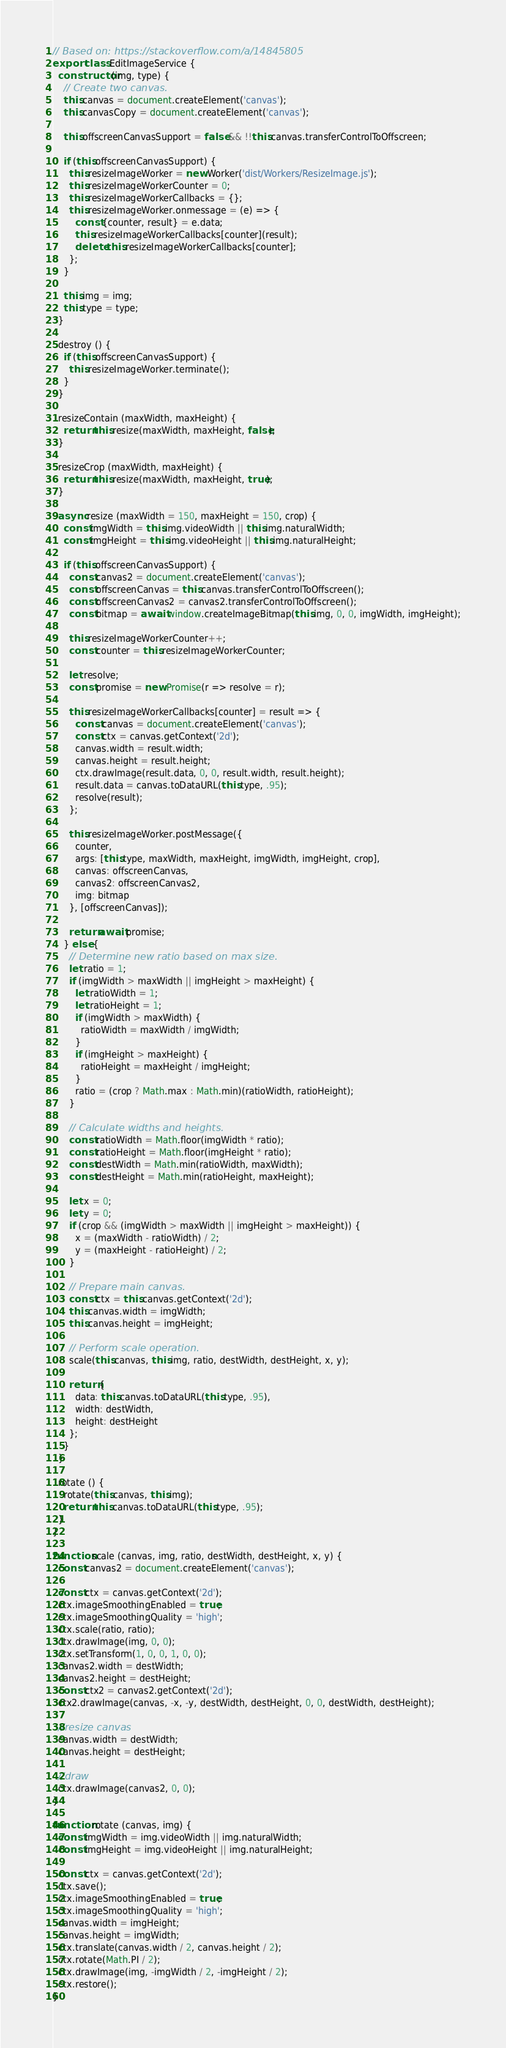Convert code to text. <code><loc_0><loc_0><loc_500><loc_500><_JavaScript_>// Based on: https://stackoverflow.com/a/14845805
export class EditImageService {
  constructor (img, type) {
    // Create two canvas.
    this.canvas = document.createElement('canvas');
    this.canvasCopy = document.createElement('canvas');

    this.offscreenCanvasSupport = false && !!this.canvas.transferControlToOffscreen;

    if (this.offscreenCanvasSupport) {
      this.resizeImageWorker = new Worker('dist/Workers/ResizeImage.js');
      this.resizeImageWorkerCounter = 0;
      this.resizeImageWorkerCallbacks = {};
      this.resizeImageWorker.onmessage = (e) => {
        const {counter, result} = e.data;
        this.resizeImageWorkerCallbacks[counter](result);
        delete this.resizeImageWorkerCallbacks[counter];
      };
    }

    this.img = img;
    this.type = type;
  }

  destroy () {
    if (this.offscreenCanvasSupport) {
      this.resizeImageWorker.terminate();
    }
  }

  resizeContain (maxWidth, maxHeight) {
    return this.resize(maxWidth, maxHeight, false);
  }

  resizeCrop (maxWidth, maxHeight) {
    return this.resize(maxWidth, maxHeight, true);
  }

  async resize (maxWidth = 150, maxHeight = 150, crop) {
    const imgWidth = this.img.videoWidth || this.img.naturalWidth;
    const imgHeight = this.img.videoHeight || this.img.naturalHeight;

    if (this.offscreenCanvasSupport) {
      const canvas2 = document.createElement('canvas');
      const offscreenCanvas = this.canvas.transferControlToOffscreen();
      const offscreenCanvas2 = canvas2.transferControlToOffscreen();
      const bitmap = await window.createImageBitmap(this.img, 0, 0, imgWidth, imgHeight);

      this.resizeImageWorkerCounter++;
      const counter = this.resizeImageWorkerCounter;

      let resolve;
      const promise = new Promise(r => resolve = r);

      this.resizeImageWorkerCallbacks[counter] = result => {
        const canvas = document.createElement('canvas');
        const ctx = canvas.getContext('2d');
        canvas.width = result.width;
        canvas.height = result.height;
        ctx.drawImage(result.data, 0, 0, result.width, result.height);
        result.data = canvas.toDataURL(this.type, .95);
        resolve(result);
      };

      this.resizeImageWorker.postMessage({
        counter,
        args: [this.type, maxWidth, maxHeight, imgWidth, imgHeight, crop],
        canvas: offscreenCanvas,
        canvas2: offscreenCanvas2,
        img: bitmap
      }, [offscreenCanvas]);

      return await promise;
    } else {
      // Determine new ratio based on max size.
      let ratio = 1;
      if (imgWidth > maxWidth || imgHeight > maxHeight) {
        let ratioWidth = 1;
        let ratioHeight = 1;
        if (imgWidth > maxWidth) {
          ratioWidth = maxWidth / imgWidth;
        }
        if (imgHeight > maxHeight) {
          ratioHeight = maxHeight / imgHeight;
        }
        ratio = (crop ? Math.max : Math.min)(ratioWidth, ratioHeight);
      }

      // Calculate widths and heights.
      const ratioWidth = Math.floor(imgWidth * ratio);
      const ratioHeight = Math.floor(imgHeight * ratio);
      const destWidth = Math.min(ratioWidth, maxWidth);
      const destHeight = Math.min(ratioHeight, maxHeight);

      let x = 0;
      let y = 0;
      if (crop && (imgWidth > maxWidth || imgHeight > maxHeight)) {
        x = (maxWidth - ratioWidth) / 2;
        y = (maxHeight - ratioHeight) / 2;
      }

      // Prepare main canvas.
      const ctx = this.canvas.getContext('2d');
      this.canvas.width = imgWidth;
      this.canvas.height = imgHeight;

      // Perform scale operation.
      scale(this.canvas, this.img, ratio, destWidth, destHeight, x, y);

      return {
        data: this.canvas.toDataURL(this.type, .95),
        width: destWidth,
        height: destHeight
      };
    }
  }

  rotate () {
    rotate(this.canvas, this.img);
    return this.canvas.toDataURL(this.type, .95);
  }
}

function scale (canvas, img, ratio, destWidth, destHeight, x, y) {
  const canvas2 = document.createElement('canvas');

  const ctx = canvas.getContext('2d');
  ctx.imageSmoothingEnabled = true;
  ctx.imageSmoothingQuality = 'high';
  ctx.scale(ratio, ratio);
  ctx.drawImage(img, 0, 0);
  ctx.setTransform(1, 0, 0, 1, 0, 0);
  canvas2.width = destWidth;
  canvas2.height = destHeight;
  const ctx2 = canvas2.getContext('2d');
  ctx2.drawImage(canvas, -x, -y, destWidth, destHeight, 0, 0, destWidth, destHeight);

  //resize canvas
  canvas.width = destWidth;
  canvas.height = destHeight;

  //draw
  ctx.drawImage(canvas2, 0, 0);
}

function rotate (canvas, img) {
  const imgWidth = img.videoWidth || img.naturalWidth;
  const imgHeight = img.videoHeight || img.naturalHeight;

  const ctx = canvas.getContext('2d');
  ctx.save();
  ctx.imageSmoothingEnabled = true;
  ctx.imageSmoothingQuality = 'high';
  canvas.width = imgHeight;
  canvas.height = imgWidth;
  ctx.translate(canvas.width / 2, canvas.height / 2);
  ctx.rotate(Math.PI / 2);
  ctx.drawImage(img, -imgWidth / 2, -imgHeight / 2);
  ctx.restore();
}
</code> 